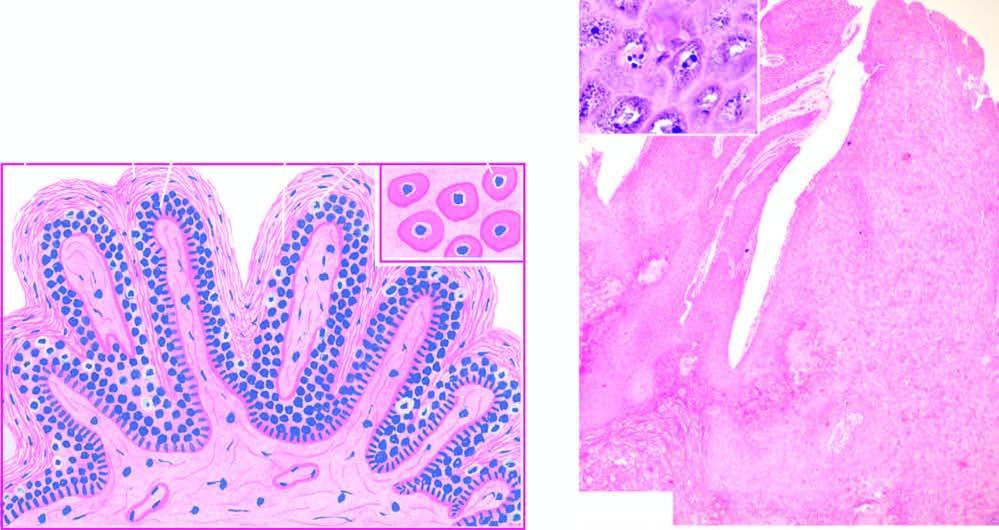what did koilocytes and virus-infected keratinocytes contain?
Answer the question using a single word or phrase. Prominent keratohyaline granules 